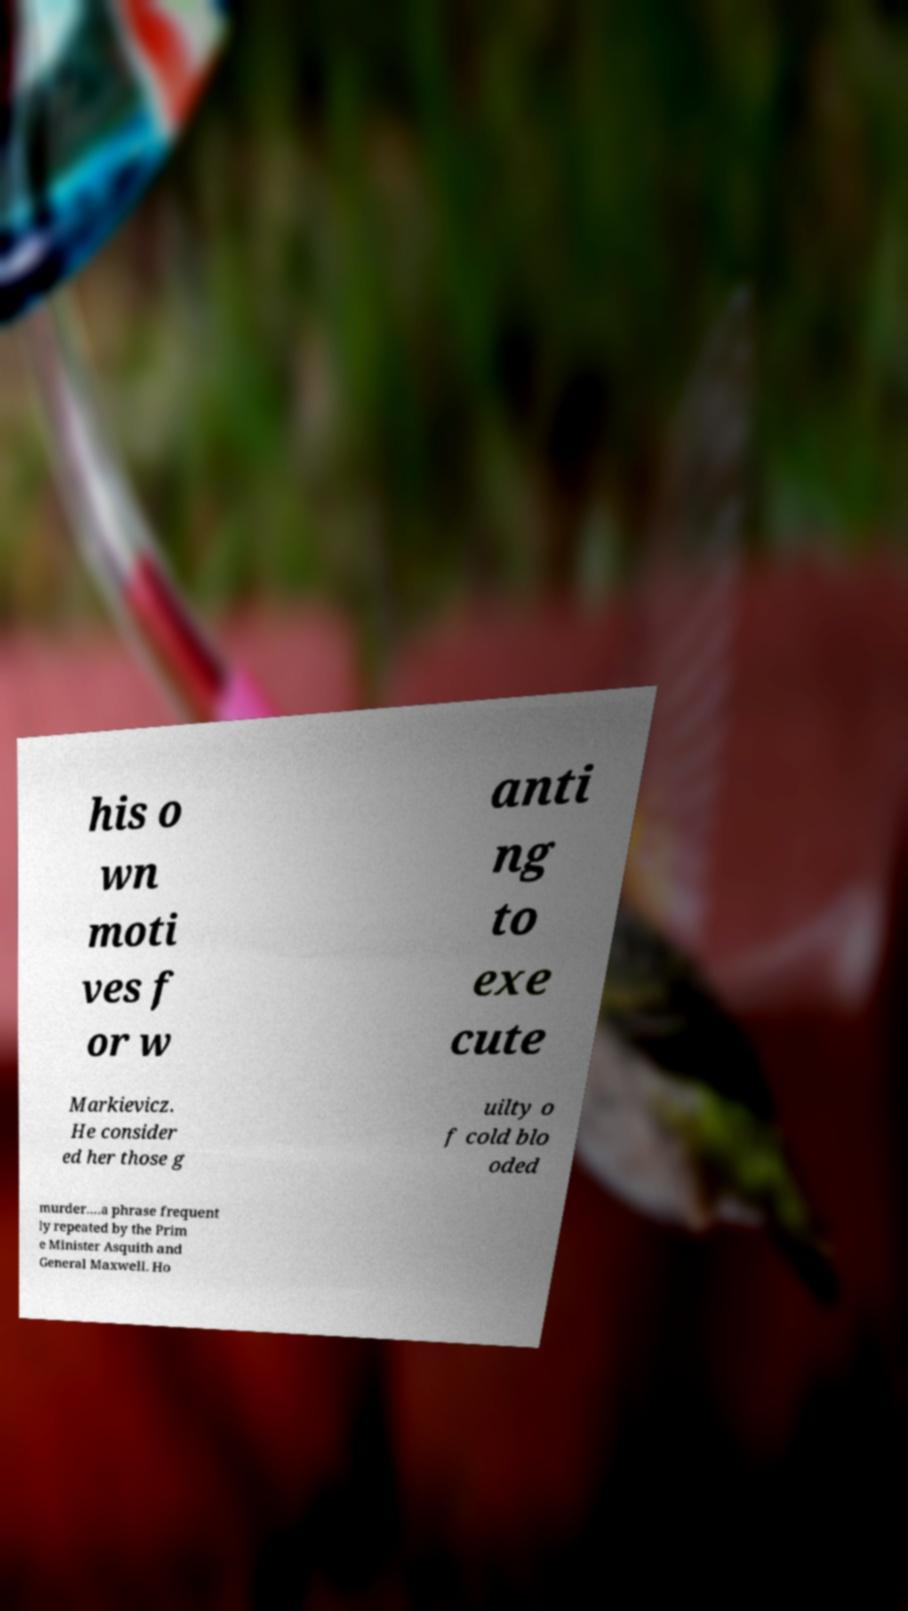Please read and relay the text visible in this image. What does it say? his o wn moti ves f or w anti ng to exe cute Markievicz. He consider ed her those g uilty o f cold blo oded murder….a phrase frequent ly repeated by the Prim e Minister Asquith and General Maxwell. Ho 